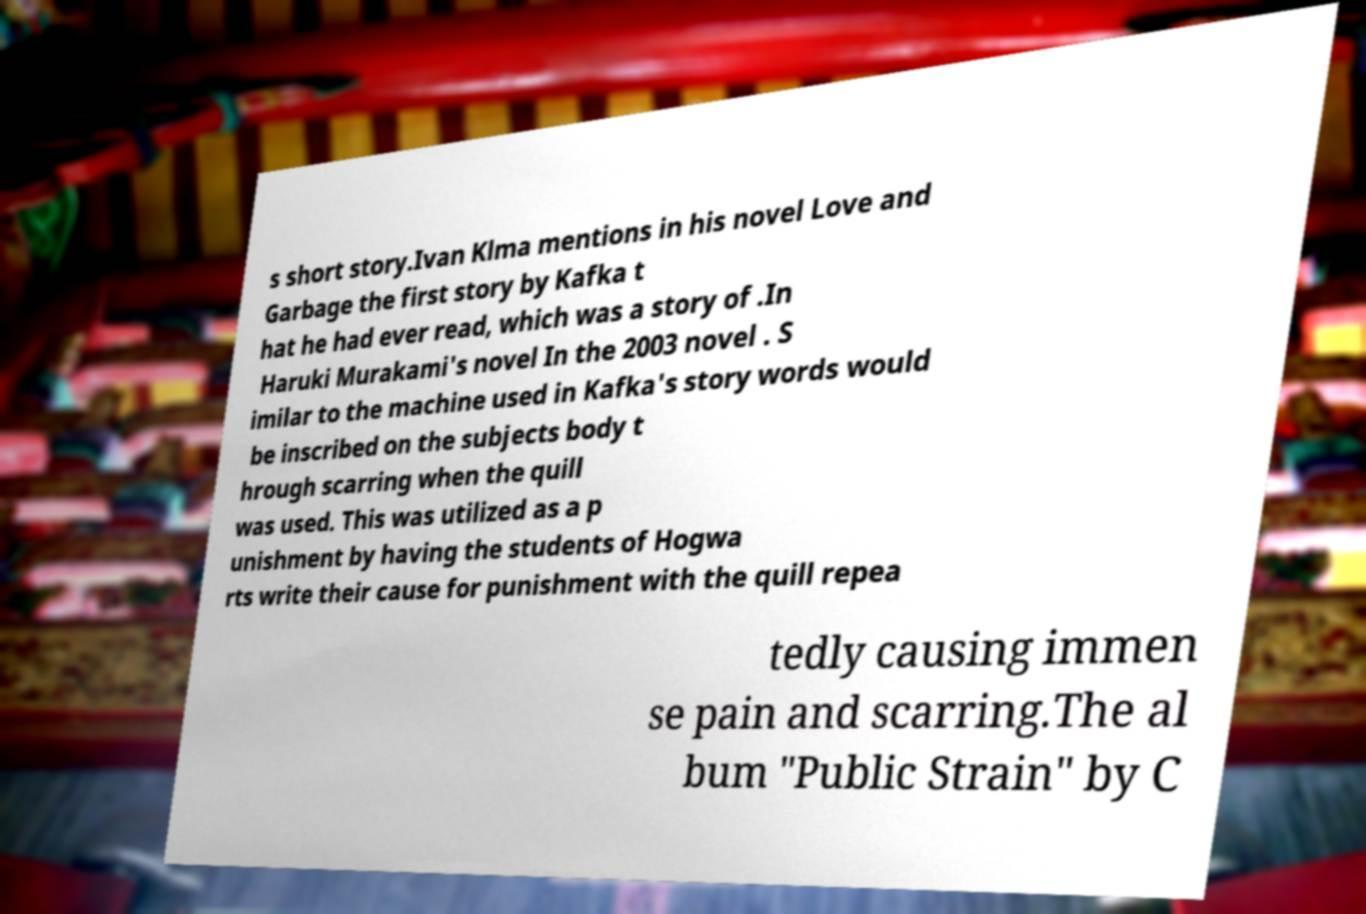Please read and relay the text visible in this image. What does it say? s short story.Ivan Klma mentions in his novel Love and Garbage the first story by Kafka t hat he had ever read, which was a story of .In Haruki Murakami's novel In the 2003 novel . S imilar to the machine used in Kafka's story words would be inscribed on the subjects body t hrough scarring when the quill was used. This was utilized as a p unishment by having the students of Hogwa rts write their cause for punishment with the quill repea tedly causing immen se pain and scarring.The al bum "Public Strain" by C 